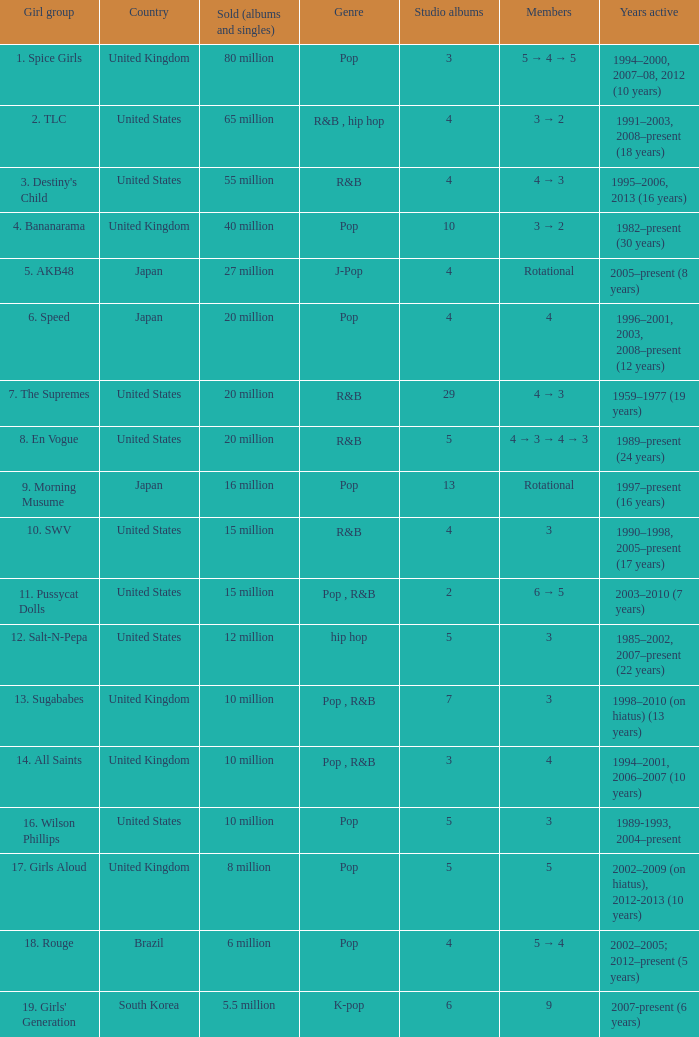What band released 29 studio albums? 7. The Supremes. 